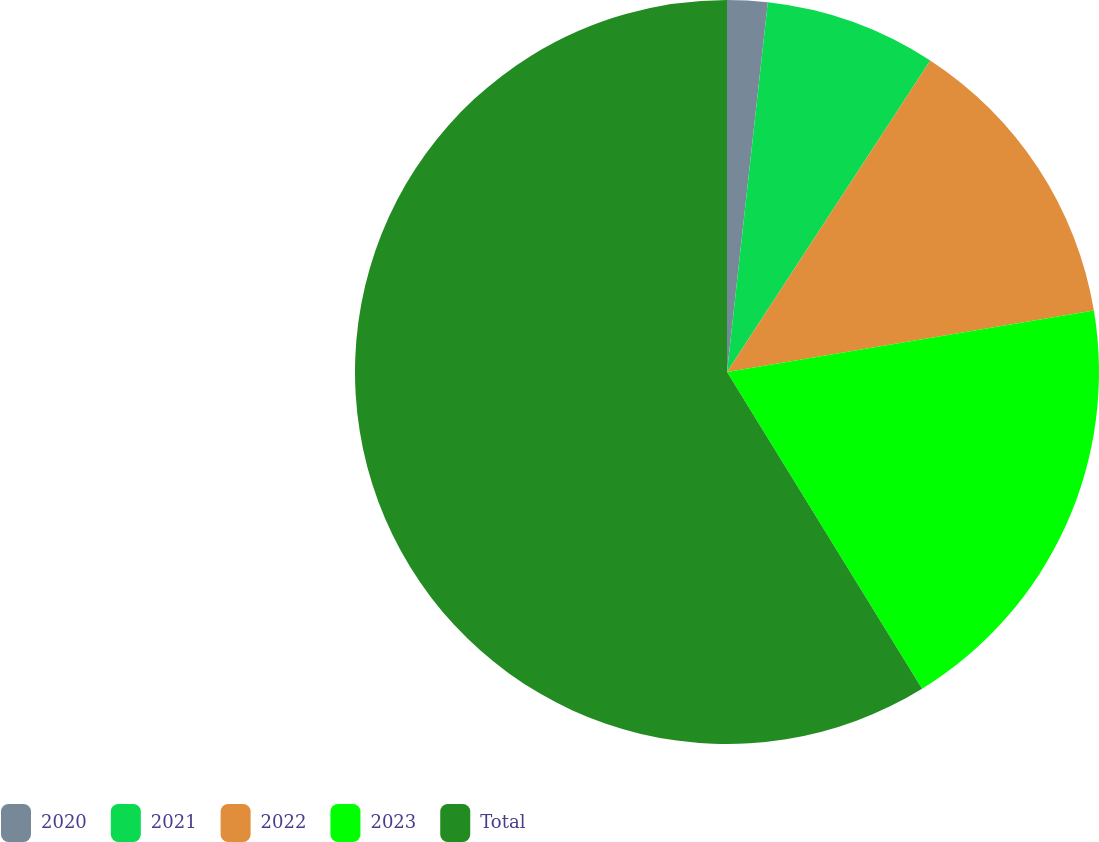Convert chart to OTSL. <chart><loc_0><loc_0><loc_500><loc_500><pie_chart><fcel>2020<fcel>2021<fcel>2022<fcel>2023<fcel>Total<nl><fcel>1.75%<fcel>7.45%<fcel>13.16%<fcel>18.86%<fcel>58.79%<nl></chart> 